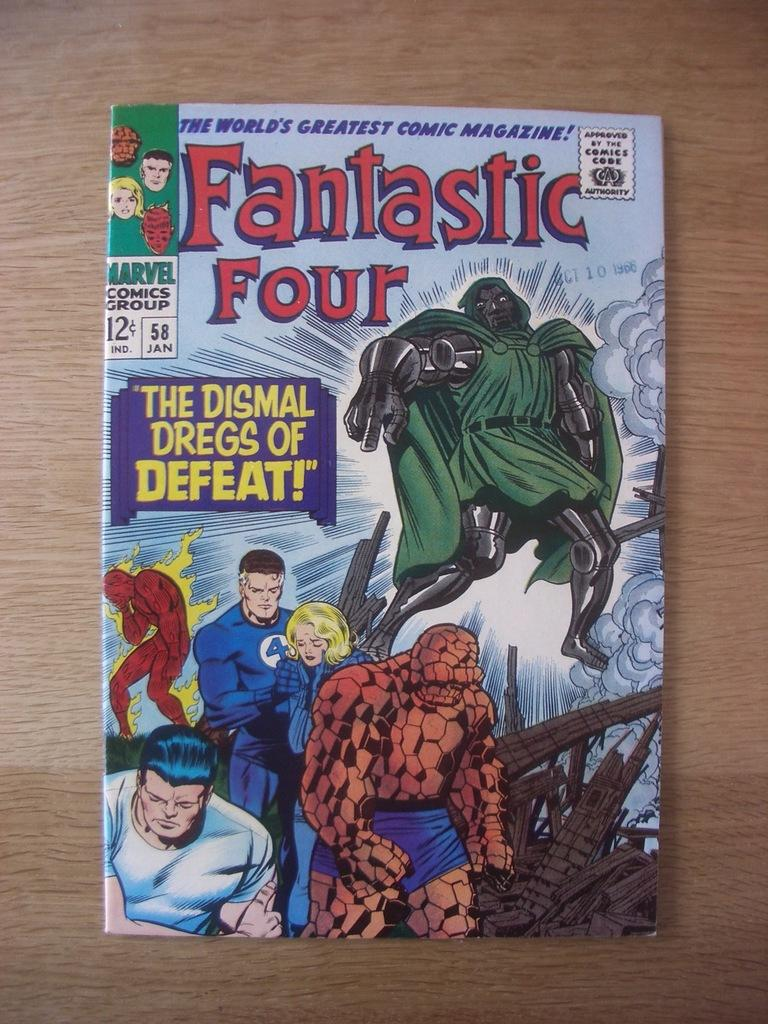<image>
Create a compact narrative representing the image presented. The cover for a Fantastic Four comic that cost 12C in Jan 1958. 